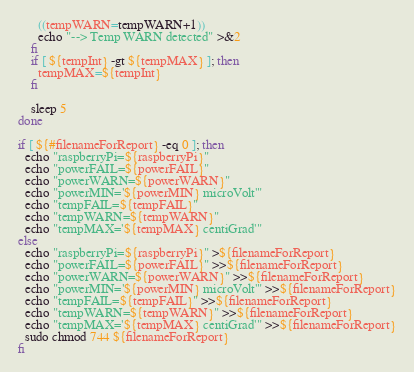<code> <loc_0><loc_0><loc_500><loc_500><_Bash_>      ((tempWARN=tempWARN+1))
      echo "--> Temp WARN detected" >&2
    fi
    if [ ${tempInt} -gt ${tempMAX} ]; then
      tempMAX=${tempInt}
    fi

	sleep 5
done

if [ ${#filenameForReport} -eq 0 ]; then
  echo "raspberryPi=${raspberryPi}"
  echo "powerFAIL=${powerFAIL}"
  echo "powerWARN=${powerWARN}"
  echo "powerMIN='${powerMIN} microVolt'"
  echo "tempFAIL=${tempFAIL}"
  echo "tempWARN=${tempWARN}"
  echo "tempMAX='${tempMAX} centiGrad'"
else
  echo "raspberryPi=${raspberryPi}" >${filenameForReport}
  echo "powerFAIL=${powerFAIL}" >>${filenameForReport}
  echo "powerWARN=${powerWARN}" >>${filenameForReport}
  echo "powerMIN='${powerMIN} microVolt'" >>${filenameForReport}
  echo "tempFAIL=${tempFAIL}" >>${filenameForReport}
  echo "tempWARN=${tempWARN}" >>${filenameForReport}
  echo "tempMAX='${tempMAX} centiGrad'" >>${filenameForReport}
  sudo chmod 744 ${filenameForReport}
fi
</code> 